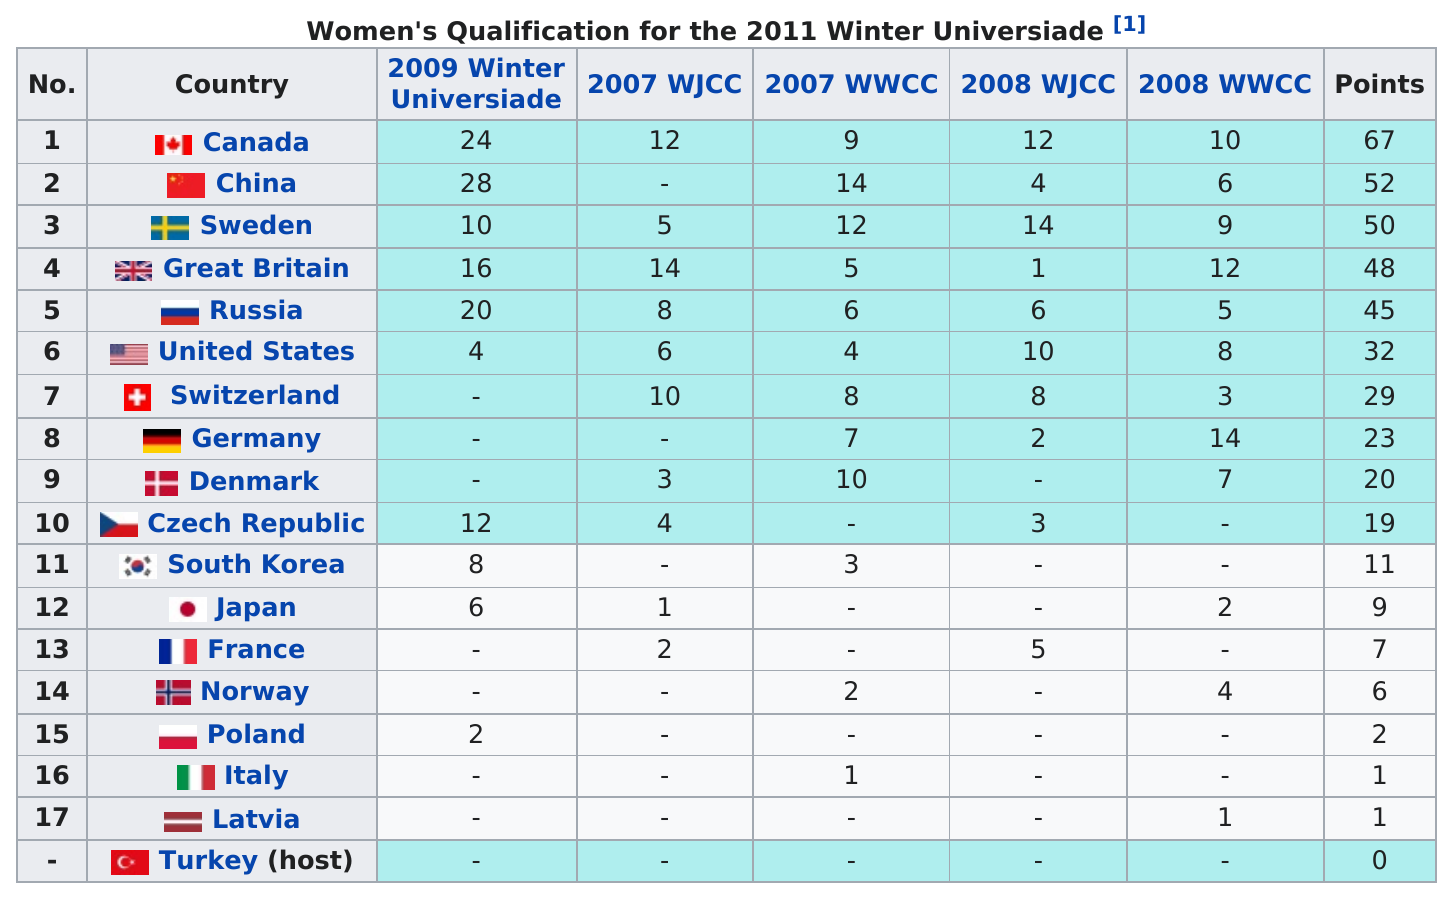Indicate a few pertinent items in this graphic. The difference between the Canadian team and the Latvian team is 66. The Canadian team scored a total of 67 points. Canada scored more than 50 total points, making it a country that achieved great success in the point-scoring competition. Italy had the same number of points as Latvia in a certain county. The average number of points scored among the top five teams was 52.4 points per game. 